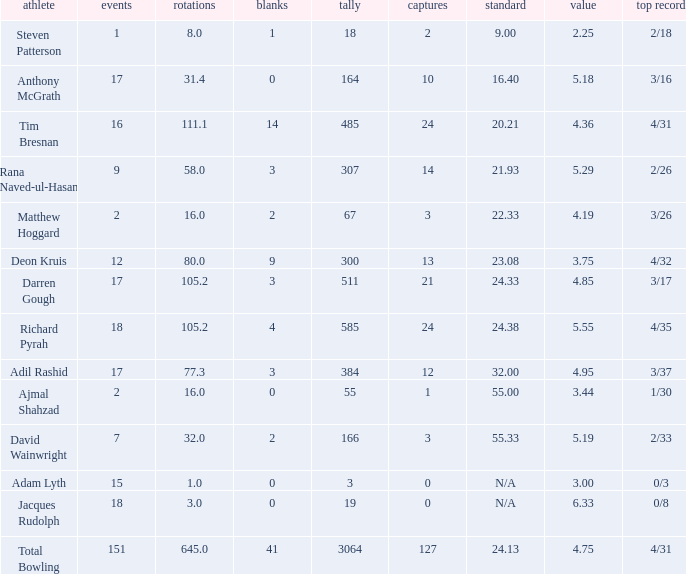What is the lowest Overs with a Run that is 18? 8.0. 